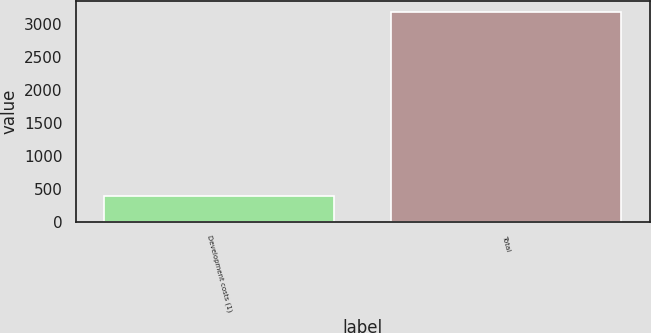<chart> <loc_0><loc_0><loc_500><loc_500><bar_chart><fcel>Development costs (1)<fcel>Total<nl><fcel>395<fcel>3183<nl></chart> 